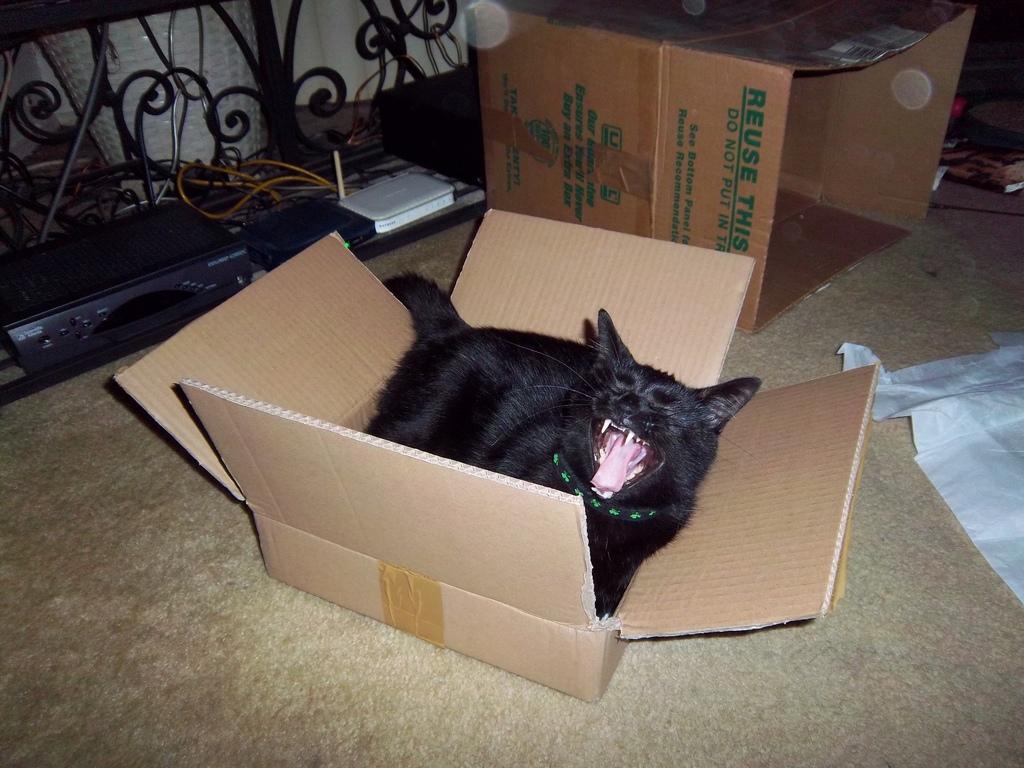What should you do with the large box?
Give a very brief answer. Unanswerable. What should you do with the box?
Keep it short and to the point. Answering does not require reading text in the image. 